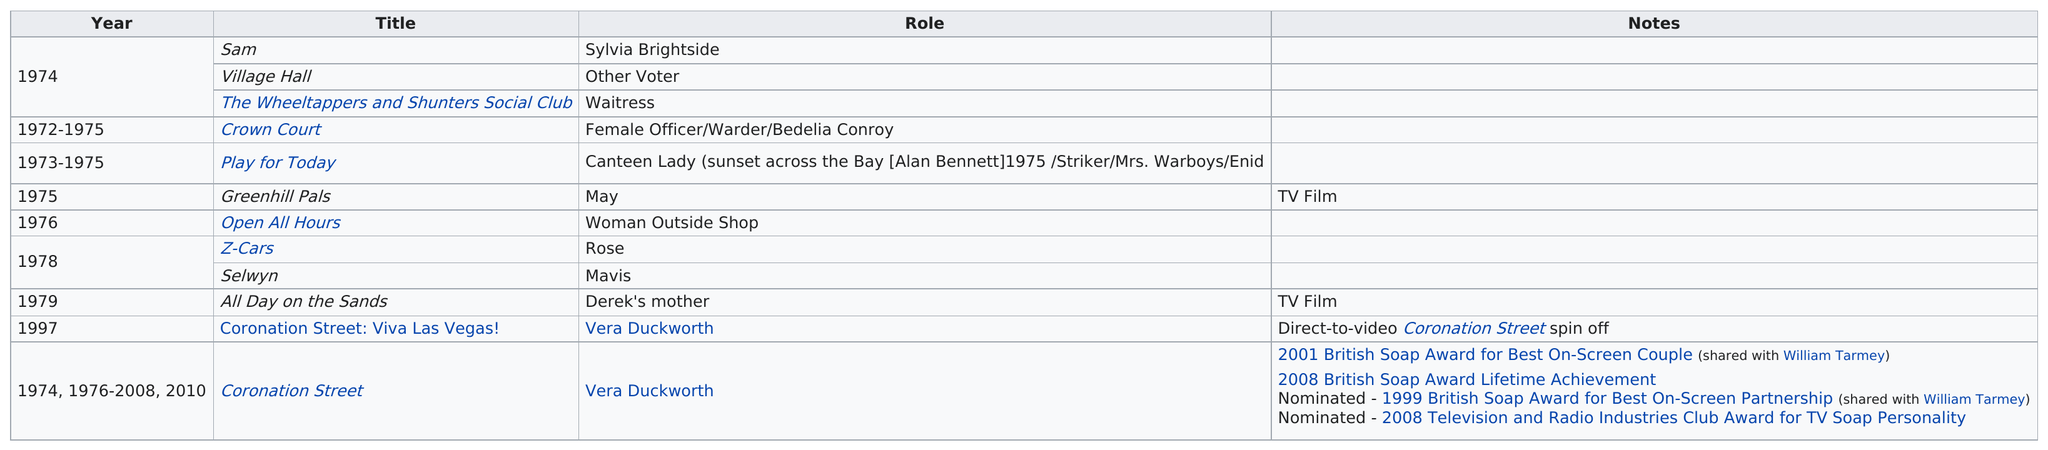Outline some significant characteristics in this image. Elizabeth Dawn has received a total of 2 awards for her work in the entertainment industry. The first time Elizabeth Dawn appeared in her role as Vera Duckworth was in 1997. 